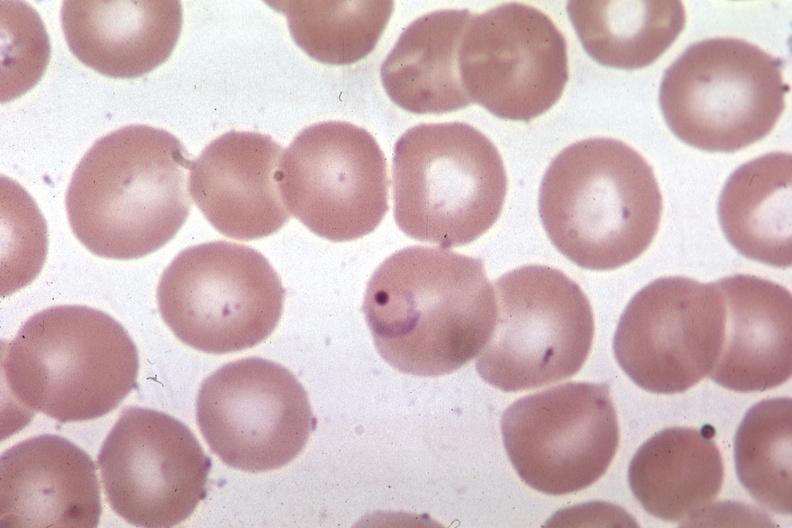s hematologic present?
Answer the question using a single word or phrase. Yes 